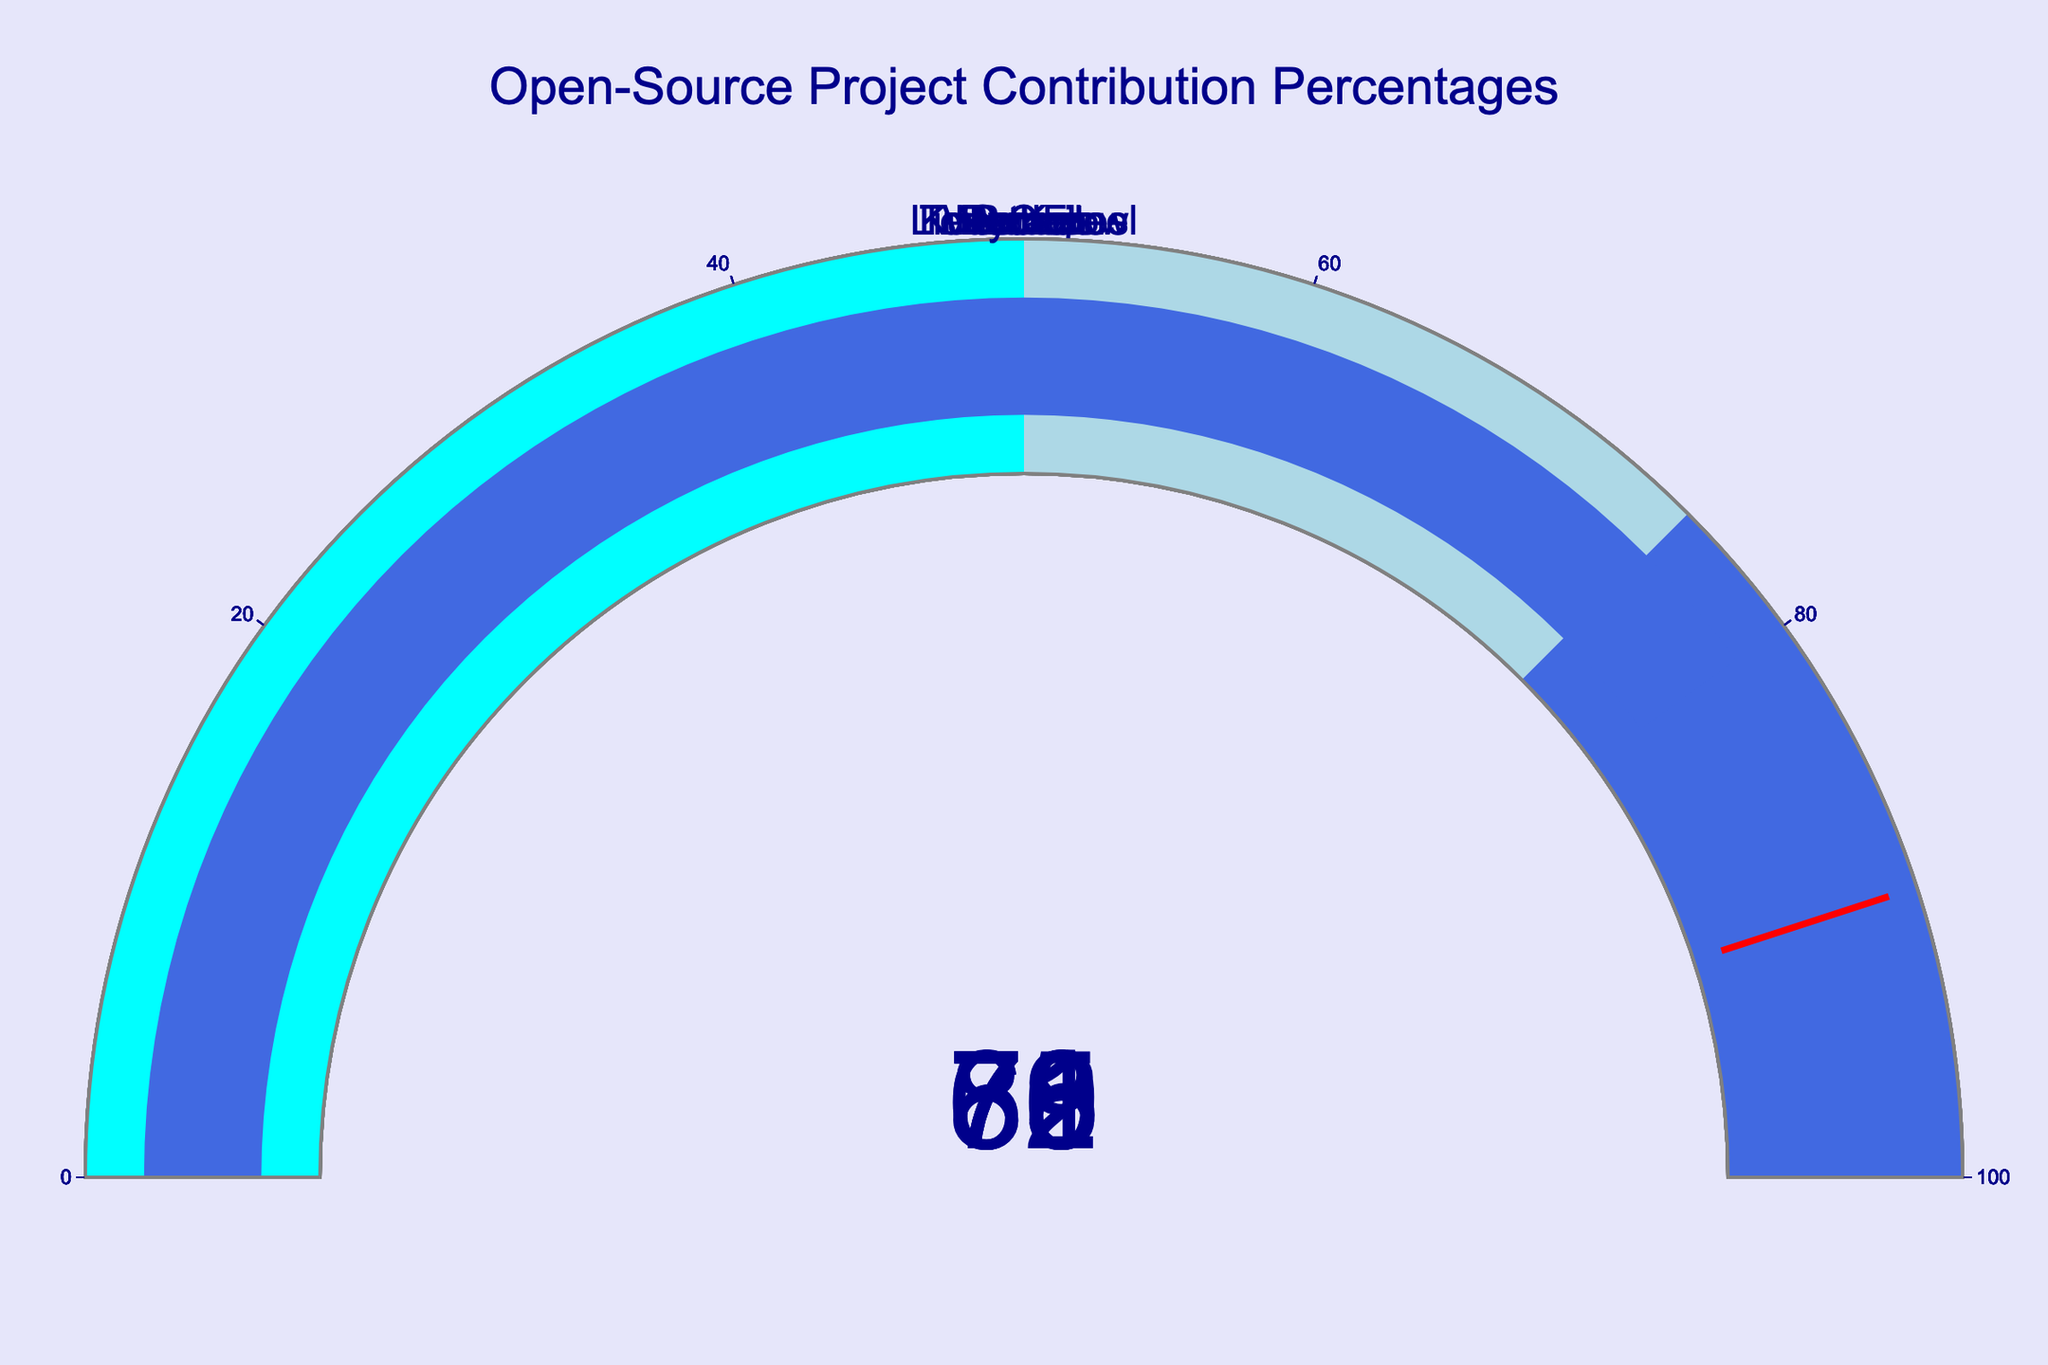What's the title of the figure? The title is usually displayed at the top of the figure in large font and helps to understand the purpose of the figure. In this case, the title is "Open-Source Project Contribution Percentages".
Answer: Open-Source Project Contribution Percentages How many projects are represented in the figure? By counting the number of gauges in the figure, we can determine the number of projects. There are 8 projects displayed.
Answer: 8 What is the contribution percentage for the React project? Locate the gauge labeled "React" and read the value inside the gauge. The React project's contribution percentage is 82%.
Answer: 82% Which project has the highest contribution percentage? By examining all the gauges, we can identify the project with the highest value. The React project has the highest contribution percentage at 82%.
Answer: React Which project has a contribution percentage of less than 70%? Look for gauges displaying values below 70%. TensorFlow has 65%, Kubernetes has 71%, and Docker has 69%. The project with below 70% is Docker.
Answer: Docker What is the average contribution percentage across all projects? Add the contribution percentages for all the projects and divide by the number of projects. (78 + 65 + 82 + 71 + 69 + 76 + 73 + 80) / 8 = 594 / 8 = 74.25
Answer: 74.25% How many projects have a contribution percentage above 75%? Count the projects with values greater than 75%. The projects are Linux Kernel (78%), React (82%), and Python (80%). Three projects have contribution percentages above 75%.
Answer: 3 Which project has a contribution percentage closest to 70%? By comparing the values, we identify that Kubernetes with 71% and Docker with 69% are closest. Among them, Docker at 69% is the closest to 70%.
Answer: Docker Is there any project with a contribution percentage in the range of 50% to 60%? By examining the values, we see that none of the projects fall within the range of 50% to 60%.
Answer: No What is the difference in contribution percentage between TensorFlow and VS Code? Subtract the contribution percentage of TensorFlow from VS Code. 76% (VS Code) - 65% (TensorFlow) = 11%.
Answer: 11% 